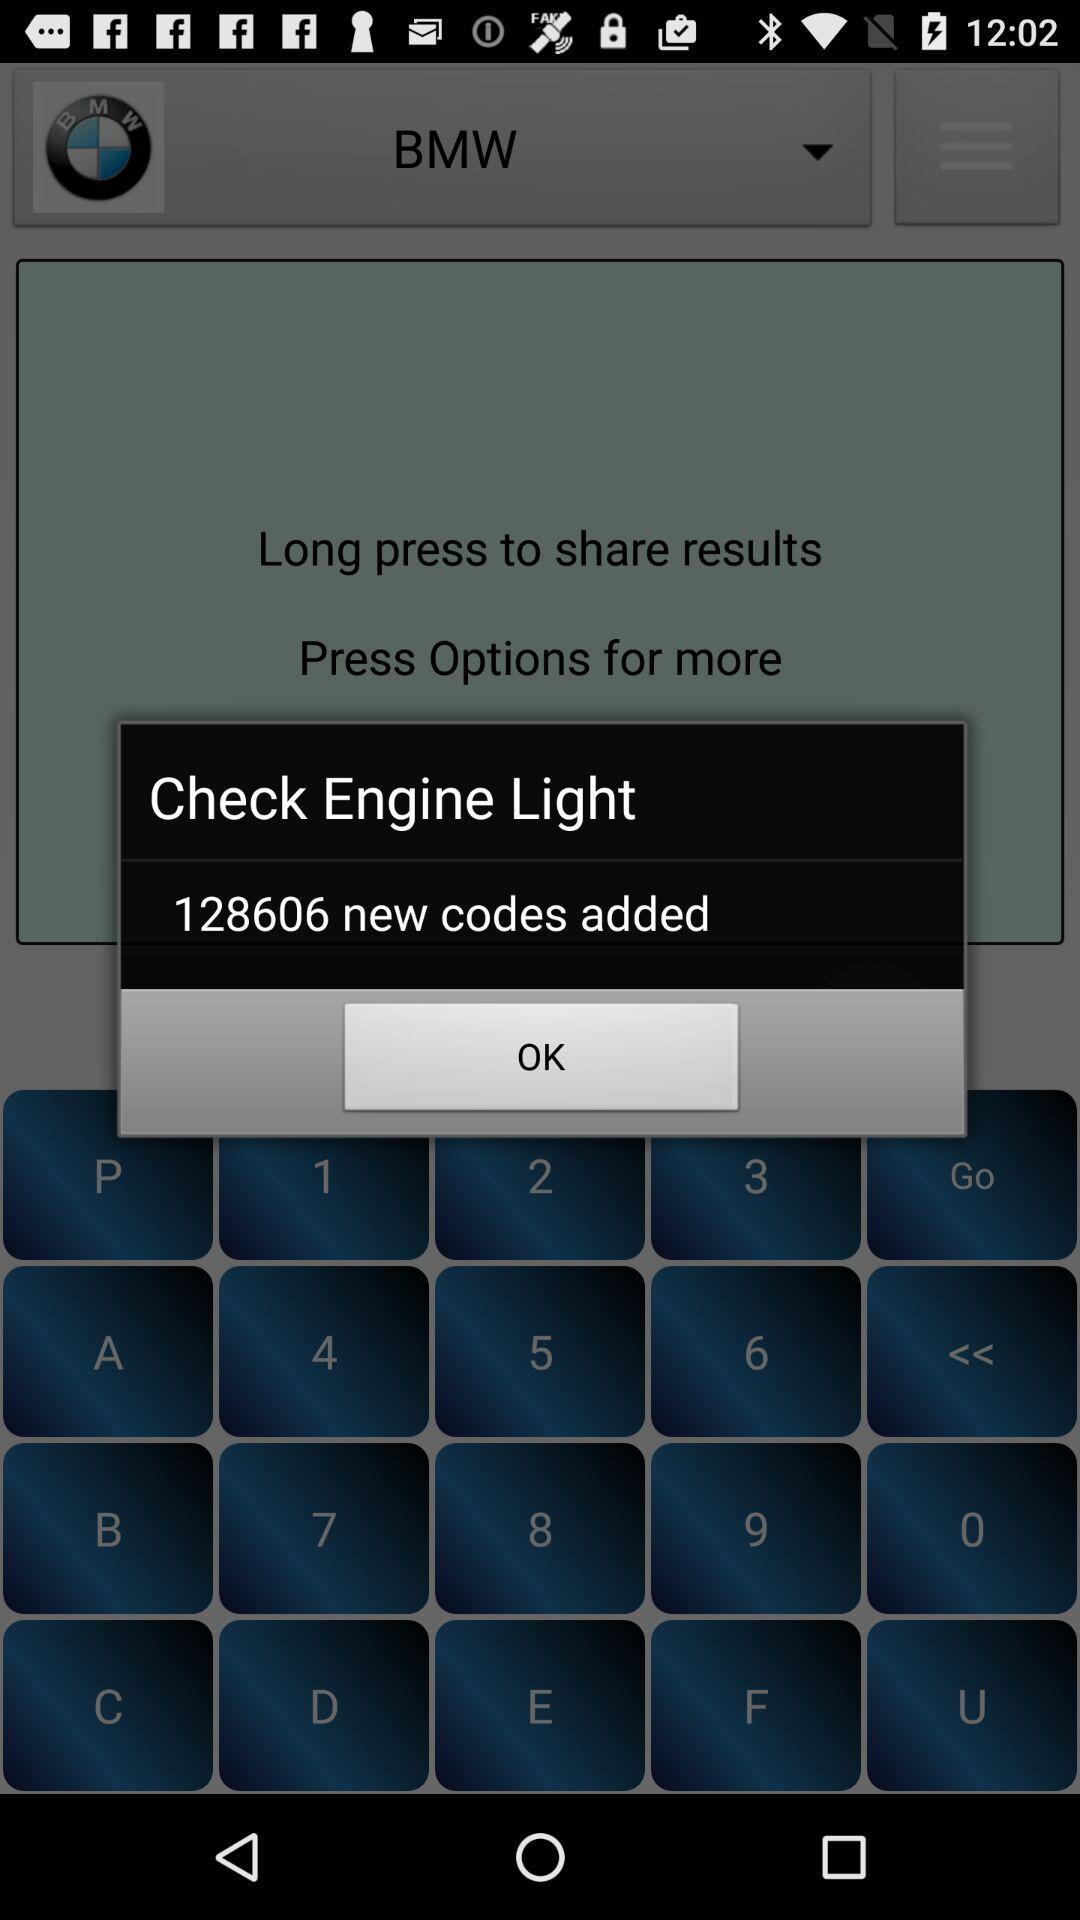What is the code that can be added?
When the provided information is insufficient, respond with <no answer>. <no answer> 